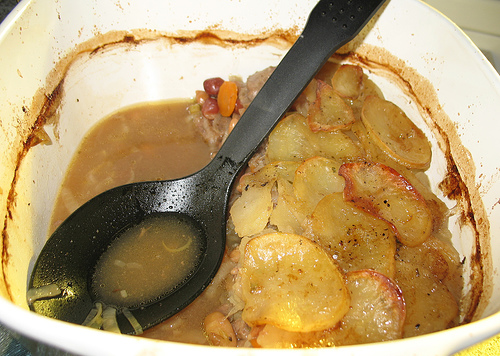<image>
Is there a spoon in the bowl? Yes. The spoon is contained within or inside the bowl, showing a containment relationship. 